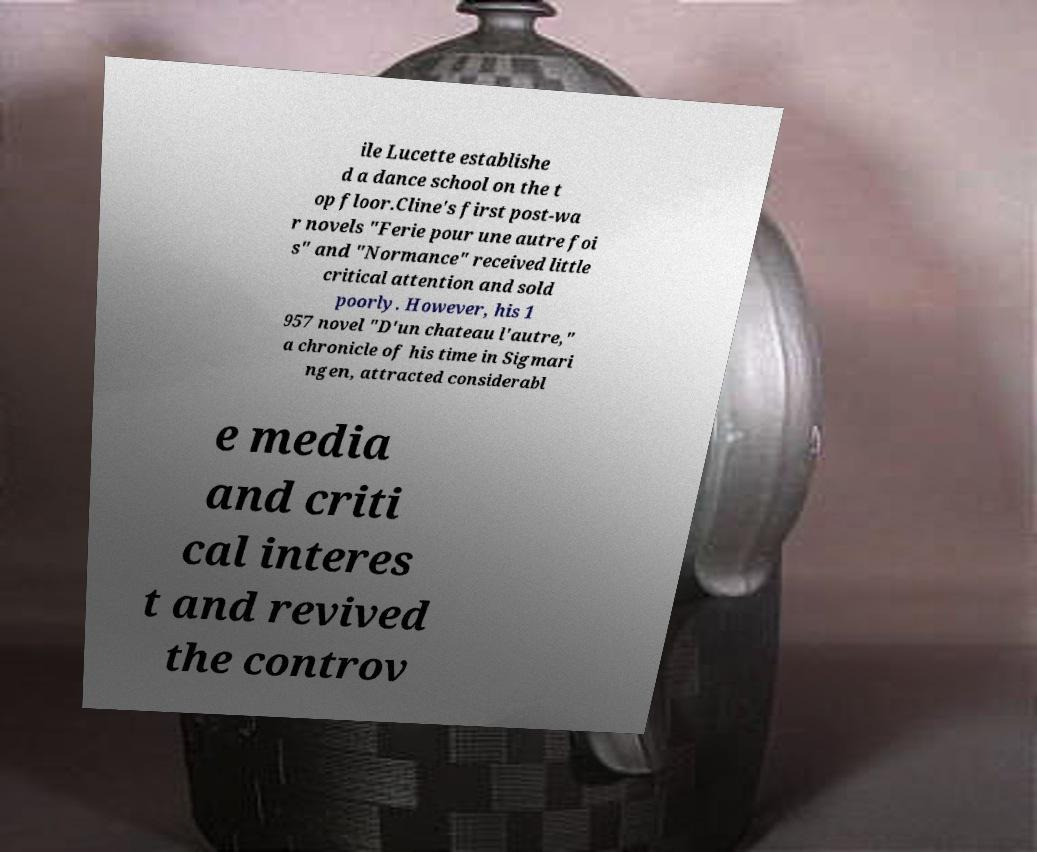Can you accurately transcribe the text from the provided image for me? ile Lucette establishe d a dance school on the t op floor.Cline's first post-wa r novels "Ferie pour une autre foi s" and "Normance" received little critical attention and sold poorly. However, his 1 957 novel "D'un chateau l'autre," a chronicle of his time in Sigmari ngen, attracted considerabl e media and criti cal interes t and revived the controv 